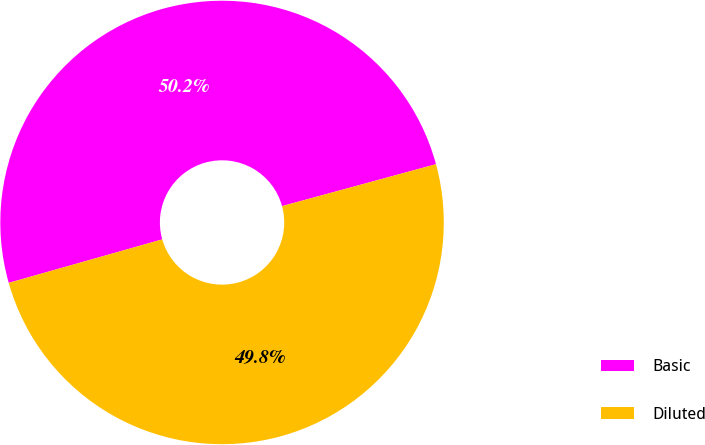<chart> <loc_0><loc_0><loc_500><loc_500><pie_chart><fcel>Basic<fcel>Diluted<nl><fcel>50.16%<fcel>49.84%<nl></chart> 